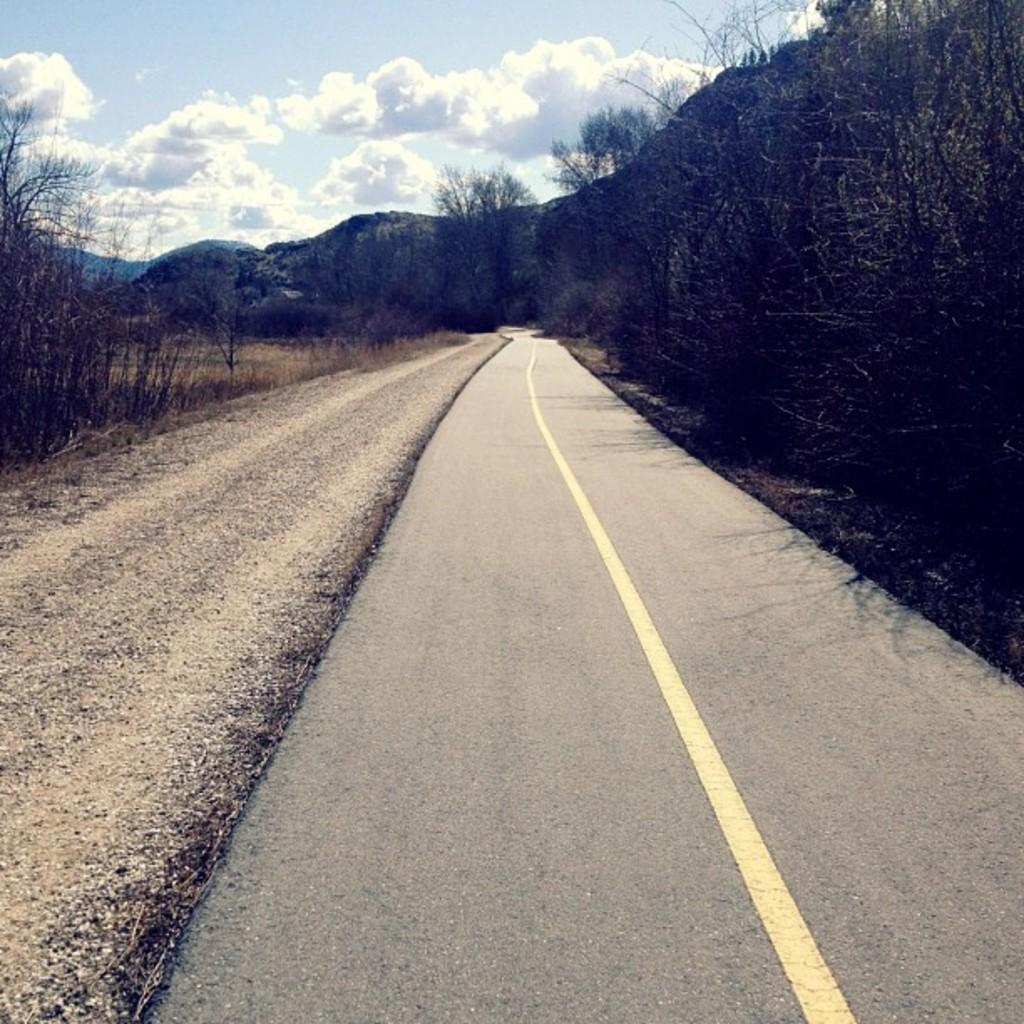What can be seen in the background of the image? There is a sky with clouds in the background of the image. What is located on either side of the road in the image? There are trees on either side of the road. What type of line divider is present on the road? There is a yellow line divider on the road. How many children are playing with the horse in the image? There are no children or horses present in the image. What color is the leaf on the tree on the right side of the road? There are no leaves mentioned in the image, only trees in general. 